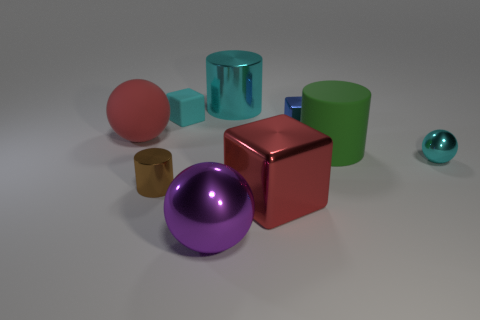Can you tell me what materials the objects seem to be made of? The objects appear to have a variety of materials: the red cube and purple sphere seem metallic with reflective surfaces, the green cylinder looks matte, possibly plastic, while the transparent blue-green cube and the small teal sphere suggest a glass or transparent plastic material. 